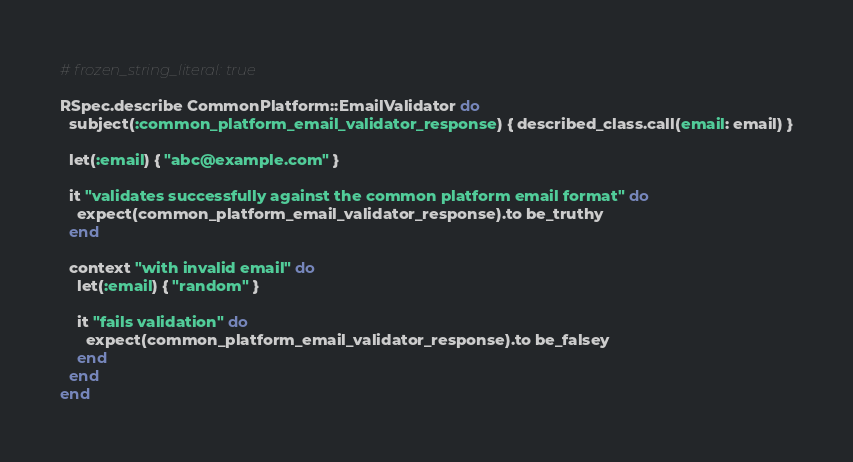<code> <loc_0><loc_0><loc_500><loc_500><_Ruby_># frozen_string_literal: true

RSpec.describe CommonPlatform::EmailValidator do
  subject(:common_platform_email_validator_response) { described_class.call(email: email) }

  let(:email) { "abc@example.com" }

  it "validates successfully against the common platform email format" do
    expect(common_platform_email_validator_response).to be_truthy
  end

  context "with invalid email" do
    let(:email) { "random" }

    it "fails validation" do
      expect(common_platform_email_validator_response).to be_falsey
    end
  end
end
</code> 